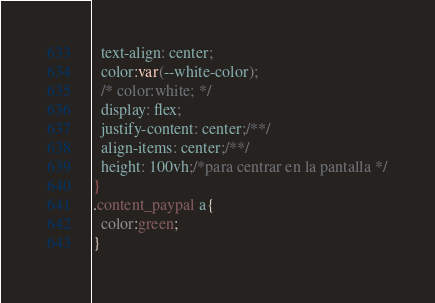Convert code to text. <code><loc_0><loc_0><loc_500><loc_500><_CSS_>  text-align: center;
  color:var(--white-color);
  /* color:white; */
  display: flex;
  justify-content: center;/**/
  align-items: center;/**/
  height: 100vh;/*para centrar en la pantalla */
}
.content_paypal a{
  color:green;
}
</code> 